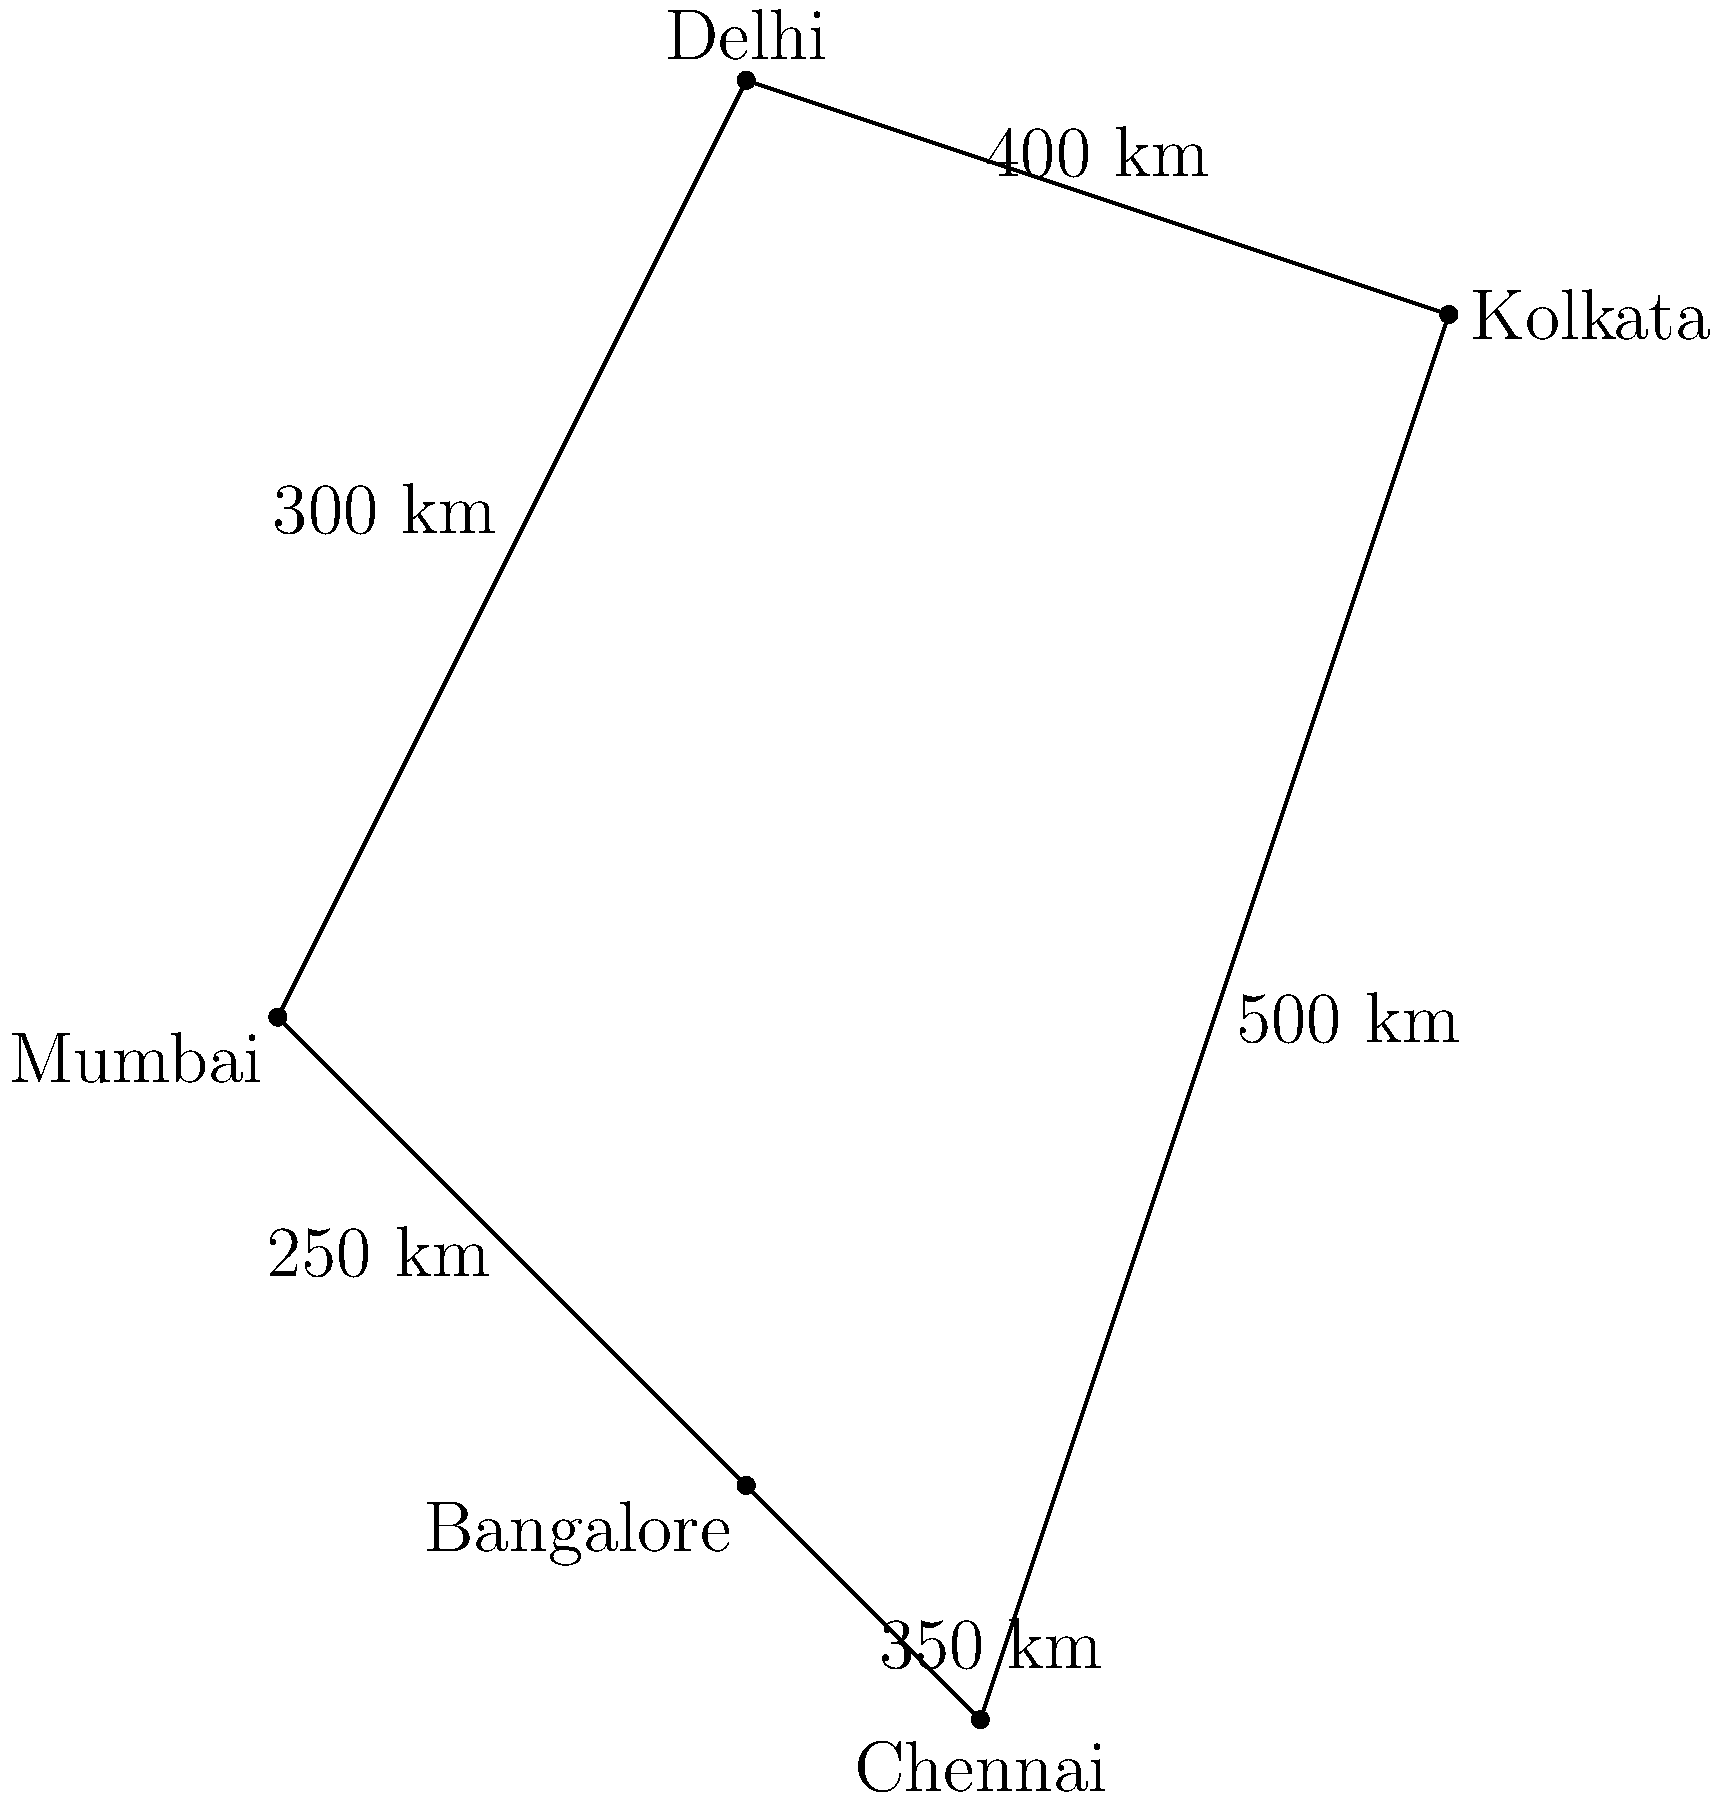As a supply chain manager, you need to transport goods from Mumbai to Kolkata. Given the map of major Indian cities and their connecting routes, which path would be the most efficient in terms of distance traveled? To find the most efficient route from Mumbai to Kolkata, we need to calculate the total distance for each possible path:

1. Mumbai -> Delhi -> Kolkata:
   Mumbai to Delhi = 300 km
   Delhi to Kolkata = 400 km
   Total = 300 + 400 = 700 km

2. Mumbai -> Bangalore -> Chennai -> Kolkata:
   Mumbai to Bangalore = 250 km
   Bangalore to Chennai = 350 km
   Chennai to Kolkata = 500 km
   Total = 250 + 350 + 500 = 1100 km

3. Mumbai -> Delhi -> Chennai -> Kolkata:
   Mumbai to Delhi = 300 km
   Delhi to Chennai ≈ 1400 km (estimated based on the map)
   Chennai to Kolkata = 500 km
   Total ≈ 300 + 1400 + 500 = 2200 km

Comparing the three options, the shortest and most efficient route is Mumbai -> Delhi -> Kolkata, with a total distance of 700 km.
Answer: Mumbai -> Delhi -> Kolkata (700 km) 